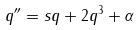Convert formula to latex. <formula><loc_0><loc_0><loc_500><loc_500>q ^ { \prime \prime } = s q + 2 q ^ { 3 } + \alpha</formula> 